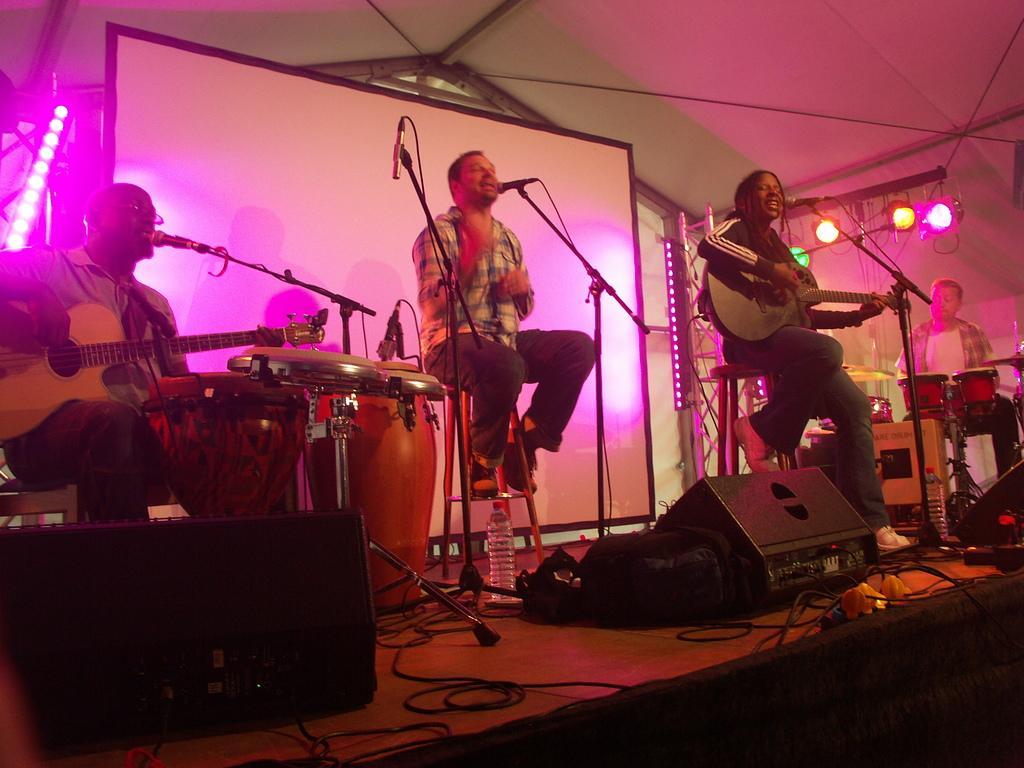Can you describe this image briefly? in this picture we can see person sitting singing songs in micro phone which is present in front of them ,two persons are playing guitar,we can also see persons playing drums, we can also see cables. 